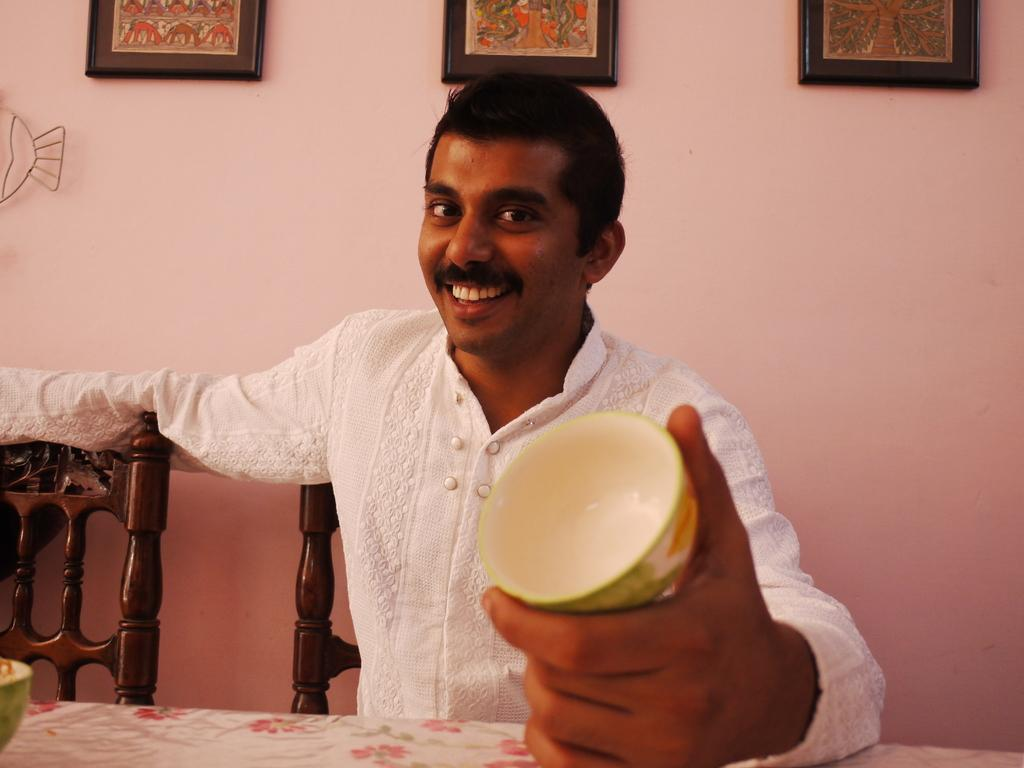What is the man in the image doing? The man is sitting on a chair in the image. What is the man holding in the image? The man is holding a bowl in the image. What can be seen on the wall in the image? There are three frames on the wall in the image. What is on the table in the image? There is a white cloth on a table in the image. How much payment is the man receiving in the image? There is no indication of payment in the image; the man is simply sitting on a chair and holding a bowl. 